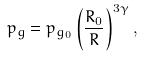<formula> <loc_0><loc_0><loc_500><loc_500>p _ { g } = p _ { g _ { 0 } } \left ( \frac { R _ { 0 } } { R } \right ) ^ { 3 \gamma } ,</formula> 